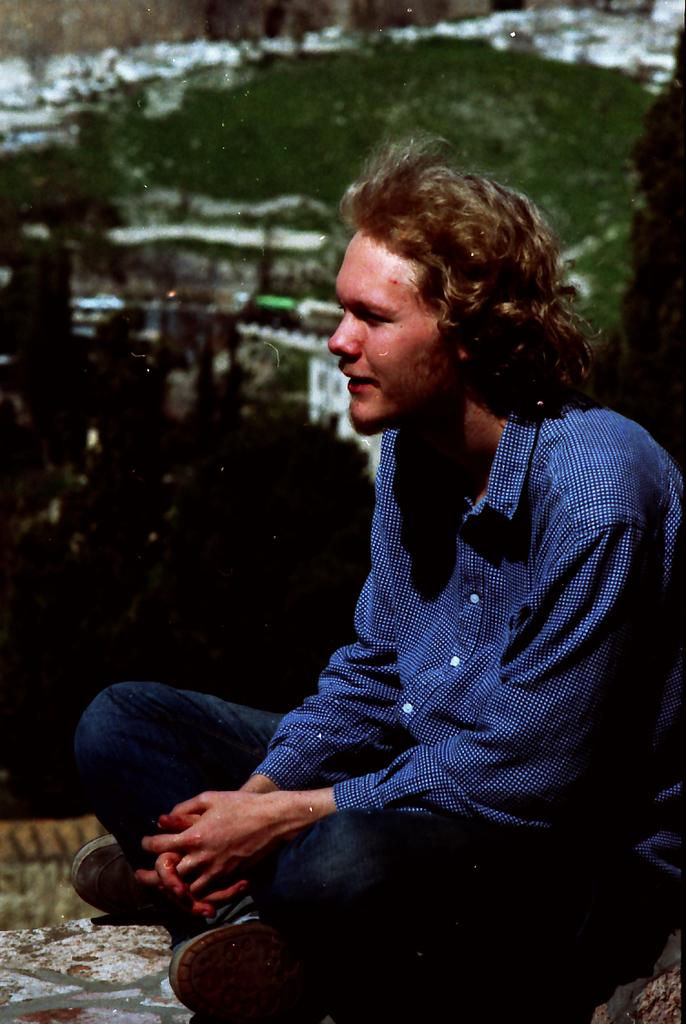What is the person in the image doing? The person is sitting on the floor in the image. Are there any objects or features near the person? There may be trees beside the person. Can you describe the background of the image? The background of the image is slightly blurred. What type of game is the person playing in the image? There is no game visible in the image; the person is simply sitting on the floor. Can you tell me how many sheets of paper are present in the image? There is no paper present in the image. 